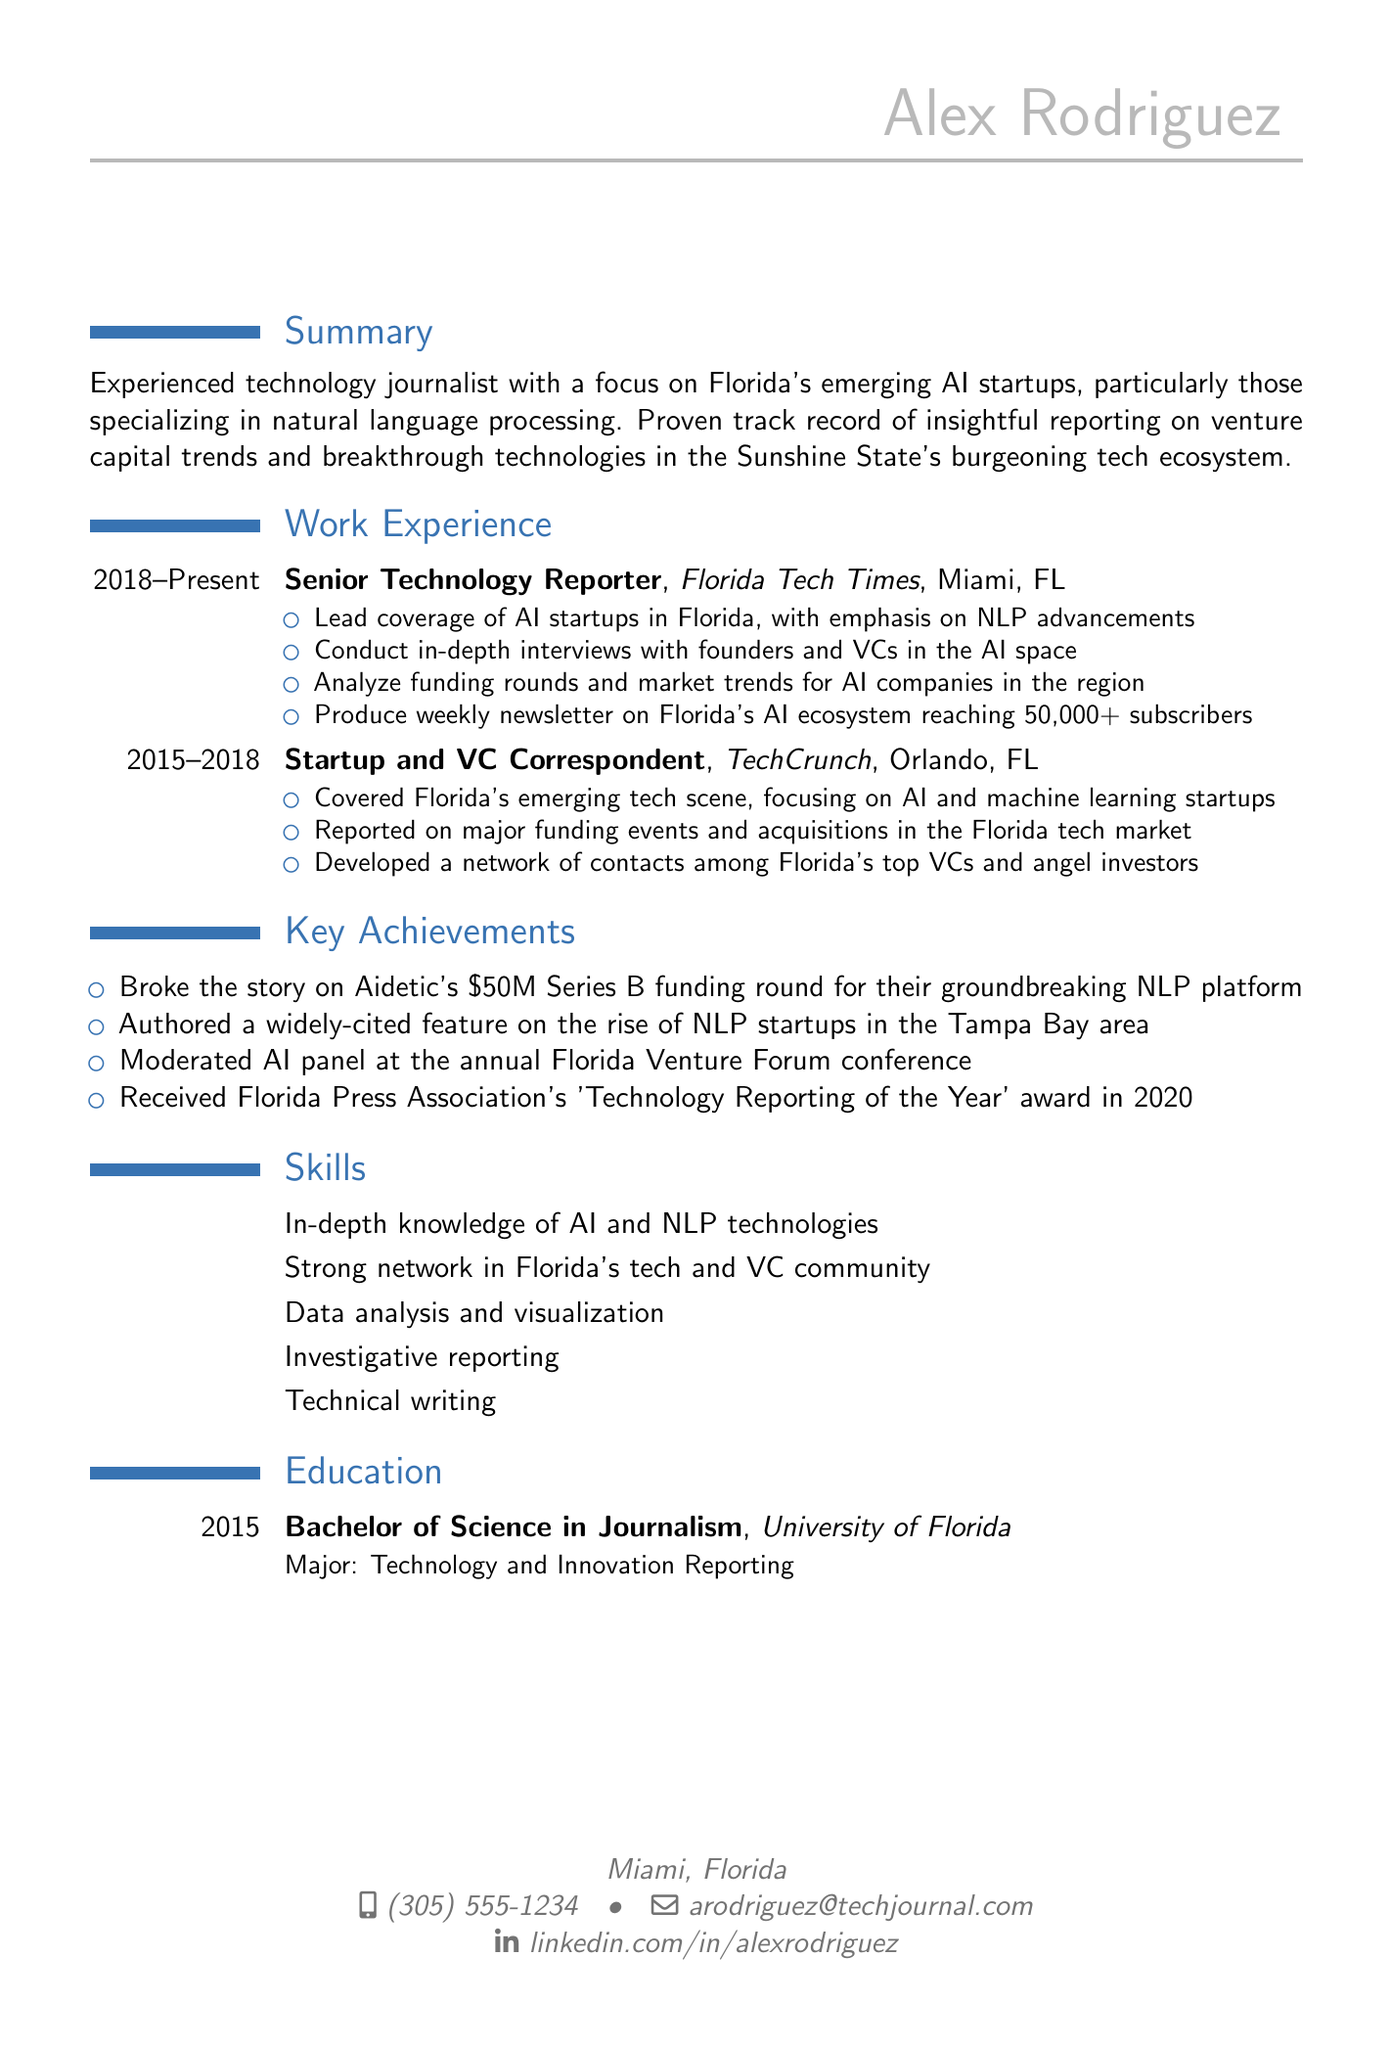What is the name of the journalist? The document lists "Alex Rodriguez" as the individual's name.
Answer: Alex Rodriguez Where does Alex Rodriguez live? The location section indicates that Alex resides in "Miami, Florida."
Answer: Miami, Florida What position does Alex currently hold? The work experience section states that Alex is a "Senior Technology Reporter."
Answer: Senior Technology Reporter In what year did Alex graduate? The education section specifies that Alex graduated in "2015."
Answer: 2015 What key achievement involves Aidetic? The key achievements mention breaking the story on Aidetic's "$50M Series B funding round."
Answer: $50M Series B funding round Which publication did Alex work for from 2015 to 2018? The work experience section identifies that Alex worked at "TechCrunch" during that period.
Answer: TechCrunch How many subscribers does the weekly newsletter reach? The responsibilities state that the newsletter reaches "50,000+ subscribers."
Answer: 50,000+ subscribers What major did Alex pursue in university? The education section reveals that Alex's major was "Technology and Innovation Reporting."
Answer: Technology and Innovation Reporting Which award did Alex receive in 2020? The key achievements list states that Alex received the "Technology Reporting of the Year" award.
Answer: Technology Reporting of the Year 